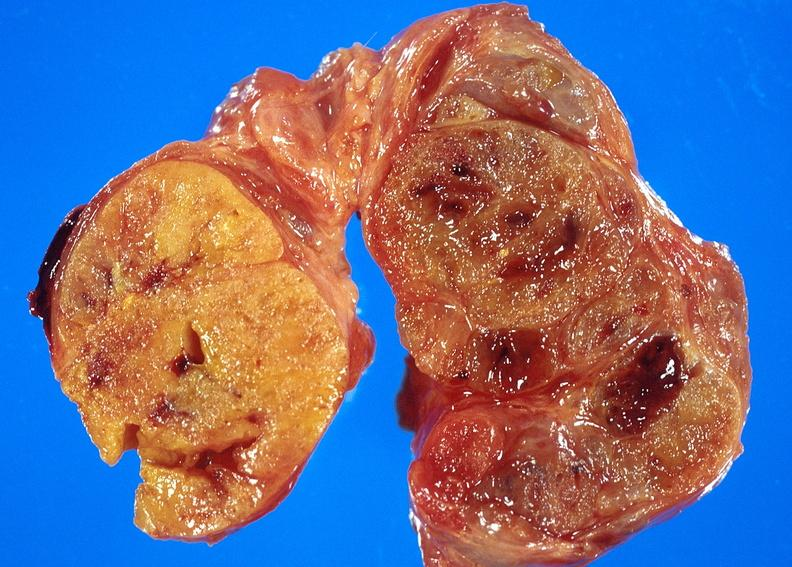what does this image show?
Answer the question using a single word or phrase. Thyroid 